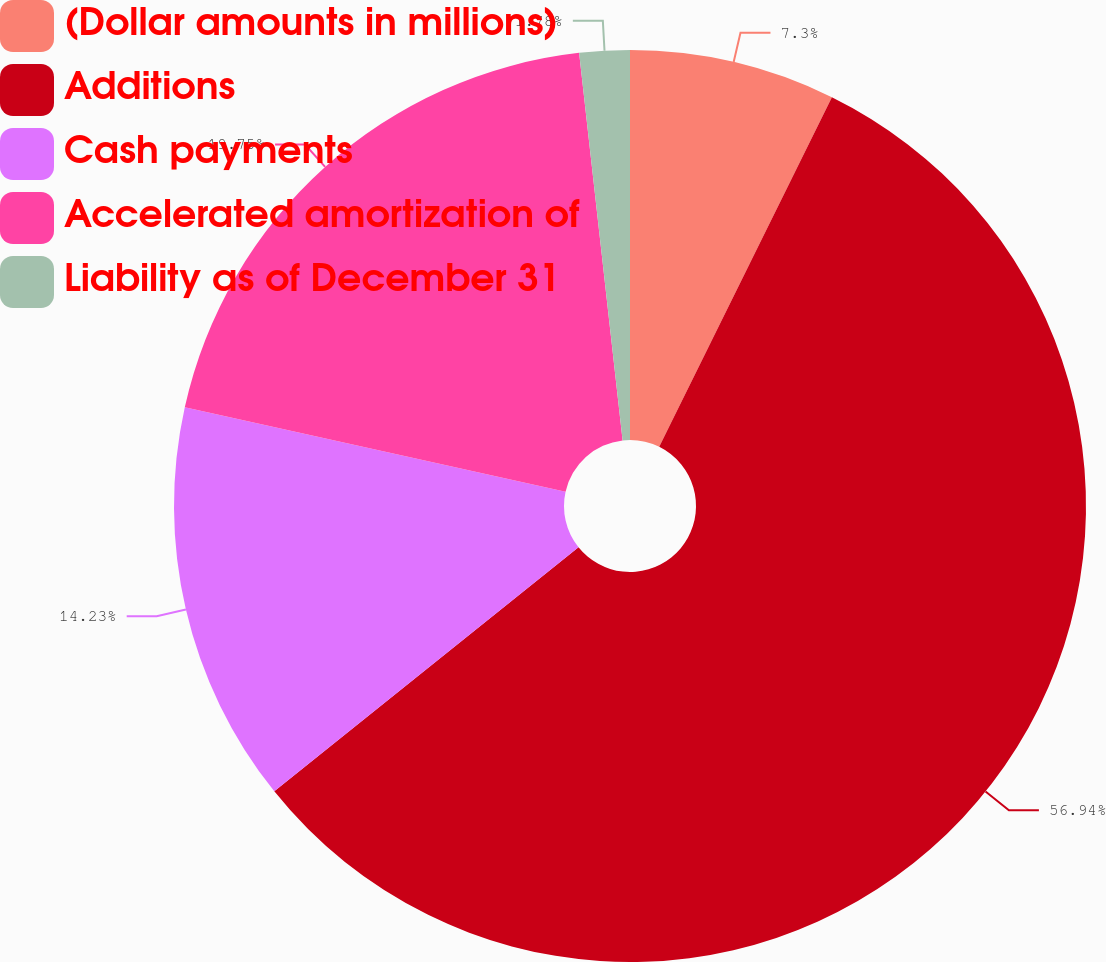Convert chart to OTSL. <chart><loc_0><loc_0><loc_500><loc_500><pie_chart><fcel>(Dollar amounts in millions)<fcel>Additions<fcel>Cash payments<fcel>Accelerated amortization of<fcel>Liability as of December 31<nl><fcel>7.3%<fcel>56.94%<fcel>14.23%<fcel>19.75%<fcel>1.78%<nl></chart> 